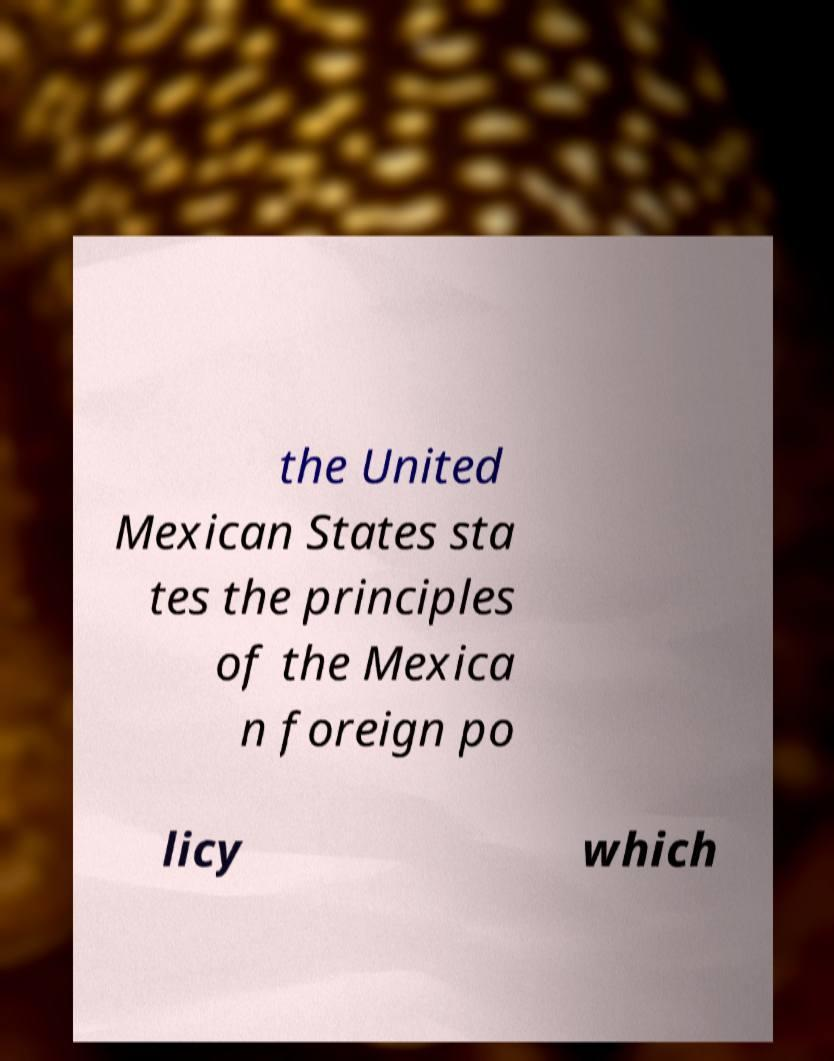There's text embedded in this image that I need extracted. Can you transcribe it verbatim? the United Mexican States sta tes the principles of the Mexica n foreign po licy which 